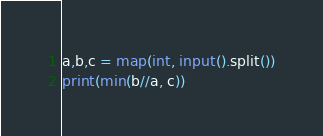<code> <loc_0><loc_0><loc_500><loc_500><_Python_>a,b,c = map(int, input().split())
print(min(b//a, c))
</code> 